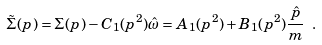<formula> <loc_0><loc_0><loc_500><loc_500>\tilde { \Sigma } ( p ) = \Sigma ( p ) - C _ { 1 } ( p ^ { 2 } ) \hat { \omega } = A _ { 1 } ( p ^ { 2 } ) + B _ { 1 } ( p ^ { 2 } ) \frac { \hat { p } } { m } \ .</formula> 